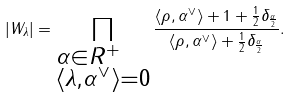Convert formula to latex. <formula><loc_0><loc_0><loc_500><loc_500>| W _ { \lambda } | = \prod _ { \begin{subarray} { c } \alpha \in R ^ { + } \\ \langle \lambda , \alpha ^ { \vee } \rangle = 0 \end{subarray} } \frac { \langle \rho , \alpha ^ { \vee } \rangle + 1 + \frac { 1 } { 2 } \delta _ { \frac { \alpha } { 2 } } } { \langle \rho , \alpha ^ { \vee } \rangle + \frac { 1 } { 2 } \delta _ { \frac { \alpha } { 2 } } } .</formula> 